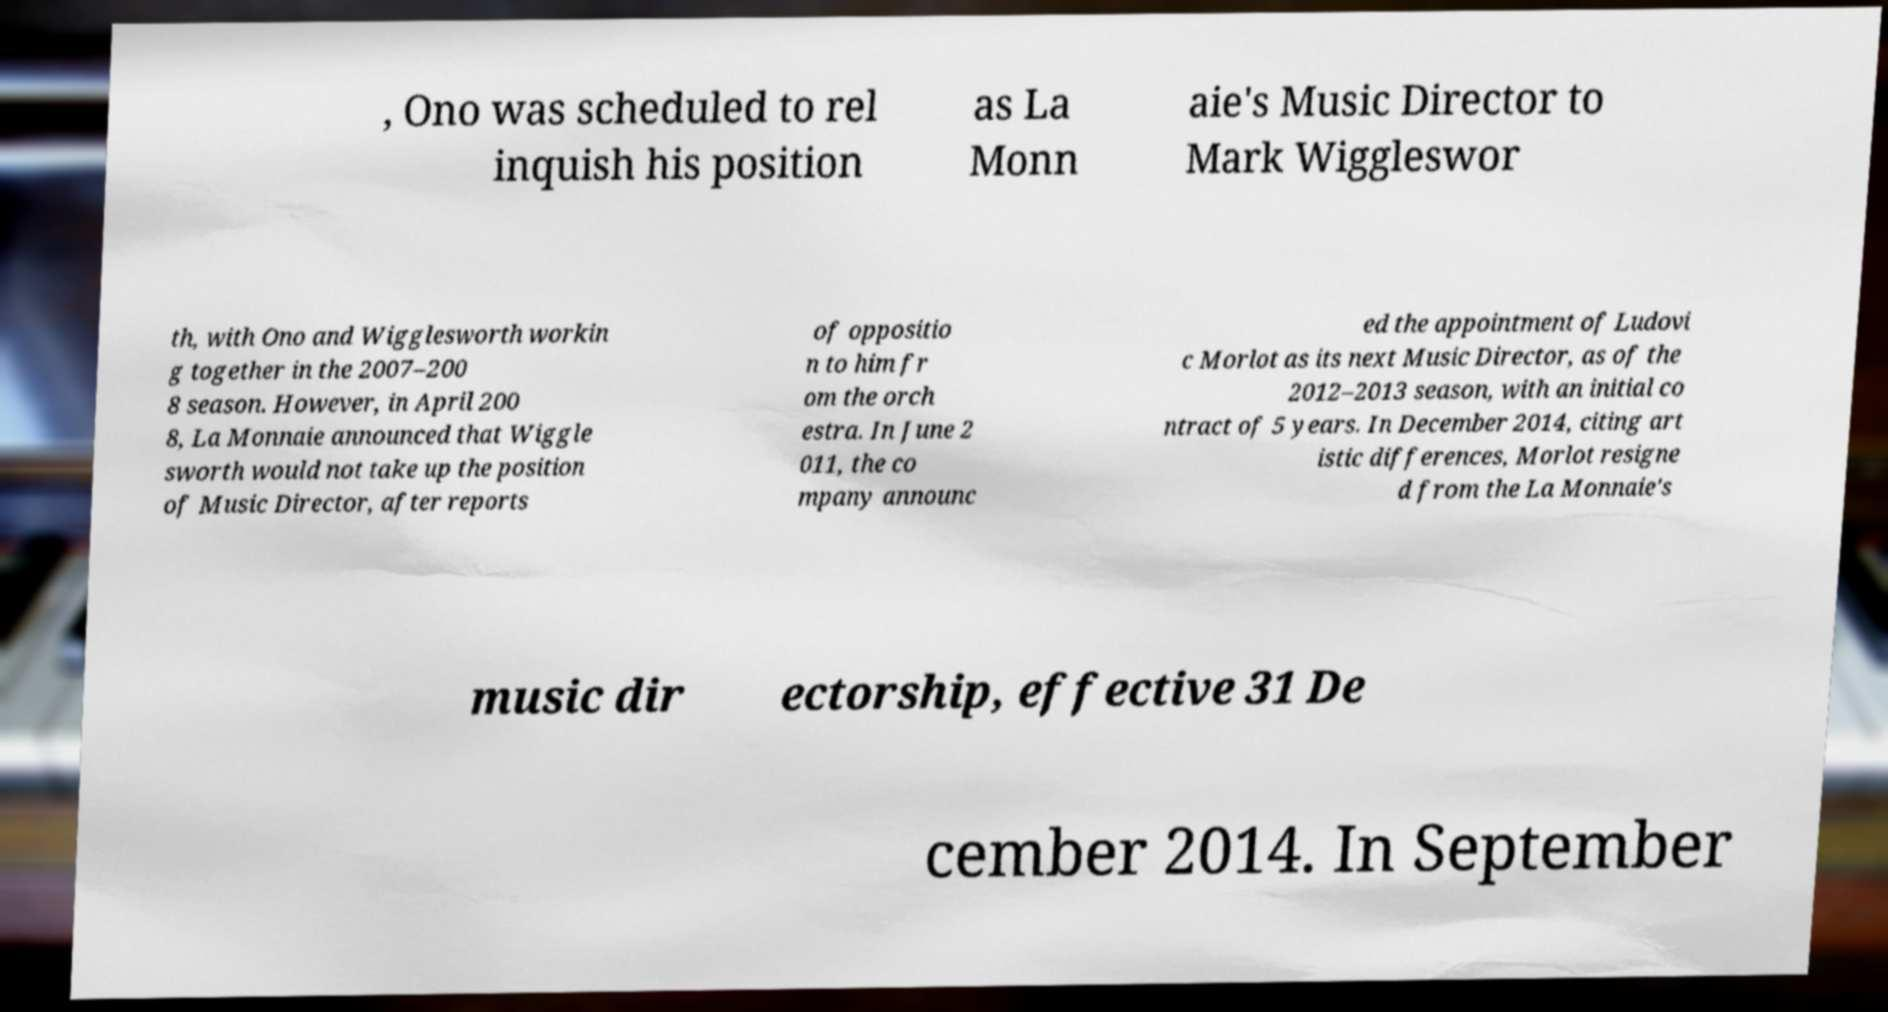Could you assist in decoding the text presented in this image and type it out clearly? , Ono was scheduled to rel inquish his position as La Monn aie's Music Director to Mark Wiggleswor th, with Ono and Wigglesworth workin g together in the 2007–200 8 season. However, in April 200 8, La Monnaie announced that Wiggle sworth would not take up the position of Music Director, after reports of oppositio n to him fr om the orch estra. In June 2 011, the co mpany announc ed the appointment of Ludovi c Morlot as its next Music Director, as of the 2012–2013 season, with an initial co ntract of 5 years. In December 2014, citing art istic differences, Morlot resigne d from the La Monnaie's music dir ectorship, effective 31 De cember 2014. In September 